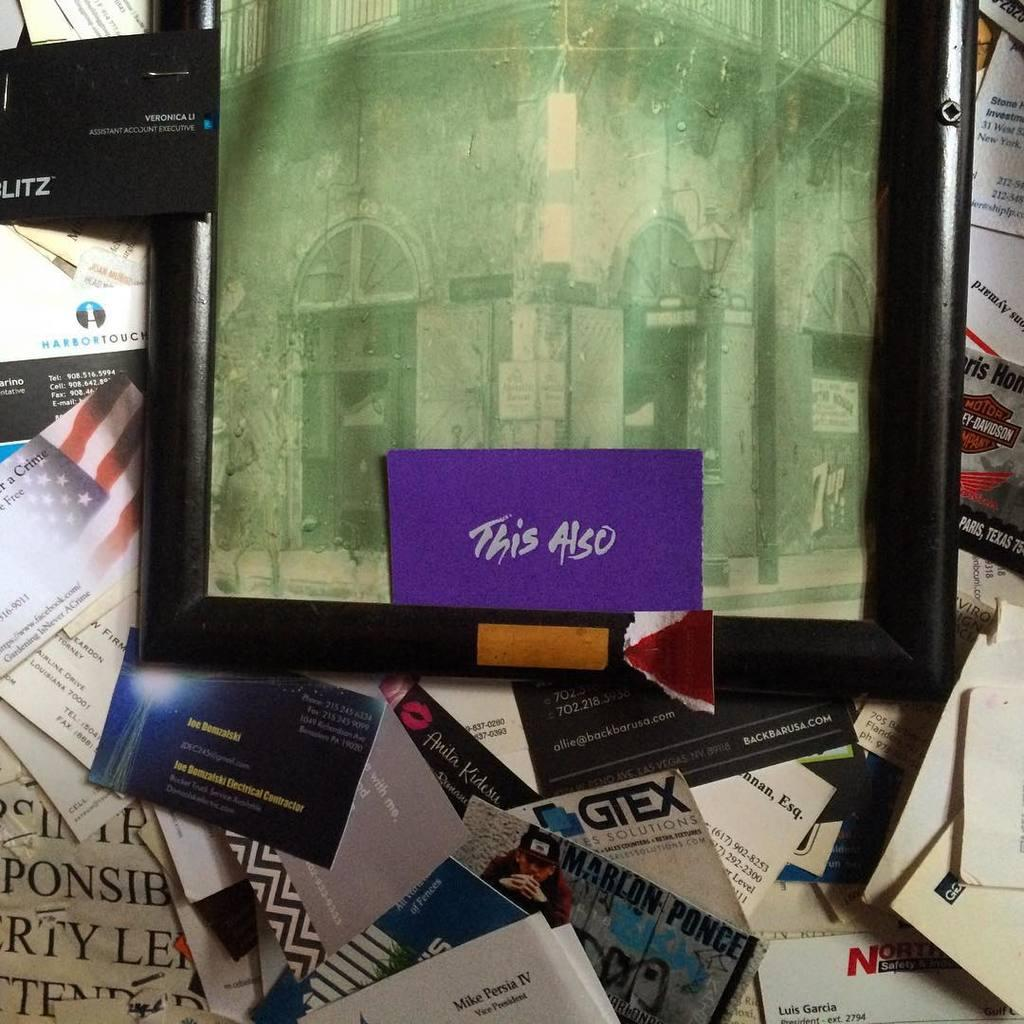<image>
Relay a brief, clear account of the picture shown. a purple piece of paper with this also written on it 